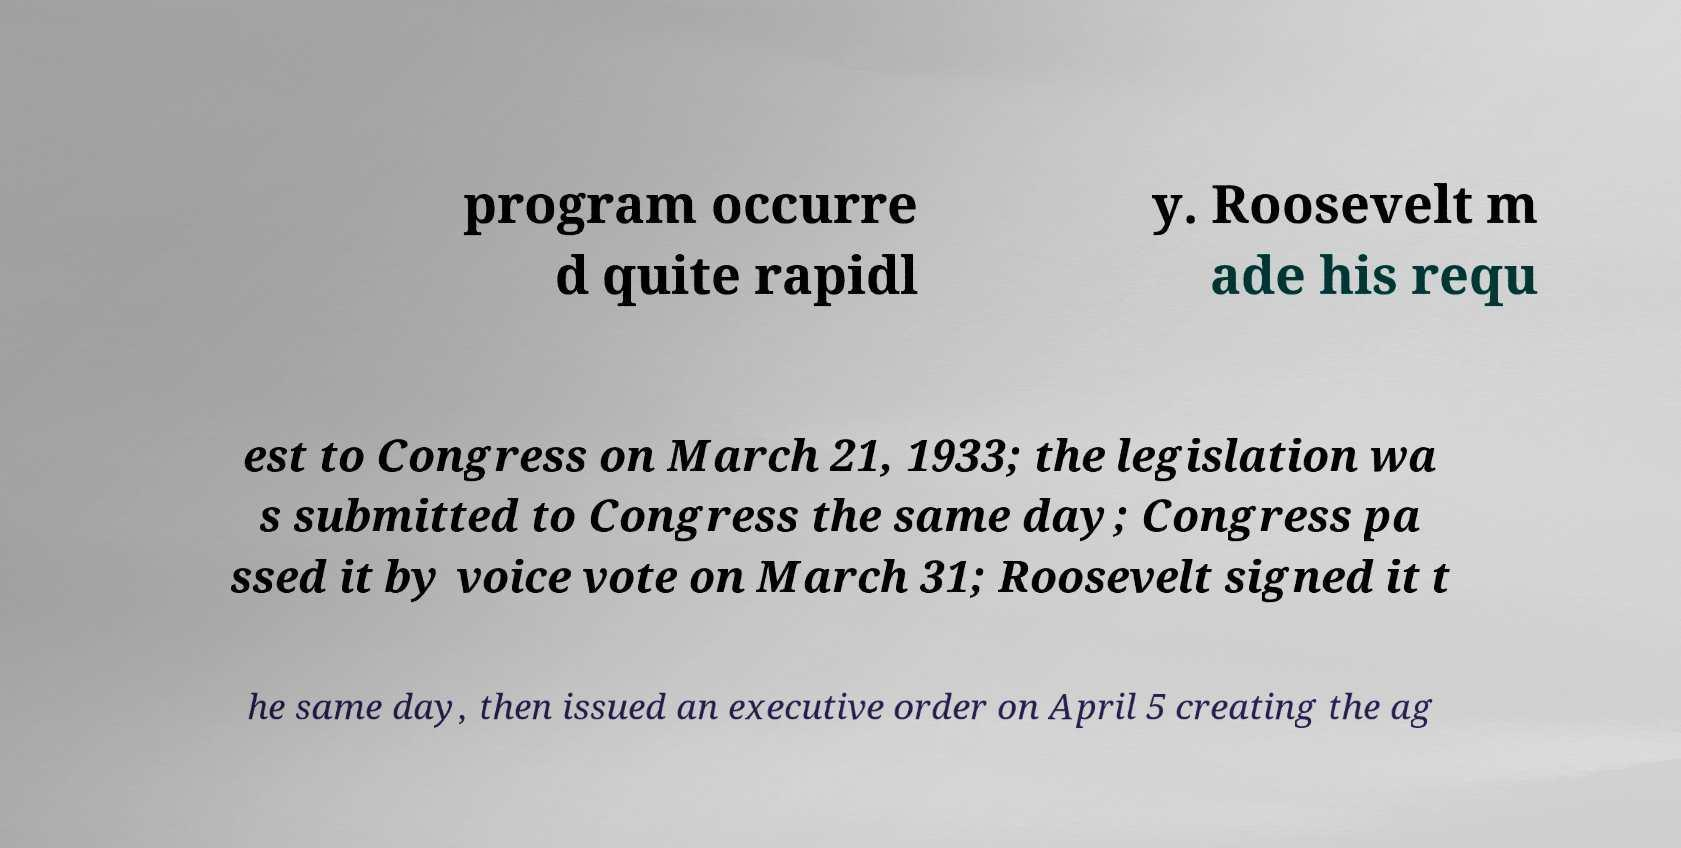There's text embedded in this image that I need extracted. Can you transcribe it verbatim? program occurre d quite rapidl y. Roosevelt m ade his requ est to Congress on March 21, 1933; the legislation wa s submitted to Congress the same day; Congress pa ssed it by voice vote on March 31; Roosevelt signed it t he same day, then issued an executive order on April 5 creating the ag 